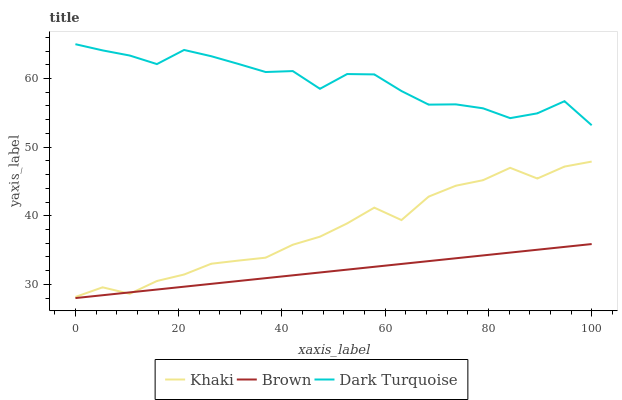Does Brown have the minimum area under the curve?
Answer yes or no. Yes. Does Dark Turquoise have the maximum area under the curve?
Answer yes or no. Yes. Does Khaki have the minimum area under the curve?
Answer yes or no. No. Does Khaki have the maximum area under the curve?
Answer yes or no. No. Is Brown the smoothest?
Answer yes or no. Yes. Is Dark Turquoise the roughest?
Answer yes or no. Yes. Is Khaki the smoothest?
Answer yes or no. No. Is Khaki the roughest?
Answer yes or no. No. Does Brown have the lowest value?
Answer yes or no. Yes. Does Khaki have the lowest value?
Answer yes or no. No. Does Dark Turquoise have the highest value?
Answer yes or no. Yes. Does Khaki have the highest value?
Answer yes or no. No. Is Brown less than Dark Turquoise?
Answer yes or no. Yes. Is Dark Turquoise greater than Khaki?
Answer yes or no. Yes. Does Khaki intersect Brown?
Answer yes or no. Yes. Is Khaki less than Brown?
Answer yes or no. No. Is Khaki greater than Brown?
Answer yes or no. No. Does Brown intersect Dark Turquoise?
Answer yes or no. No. 